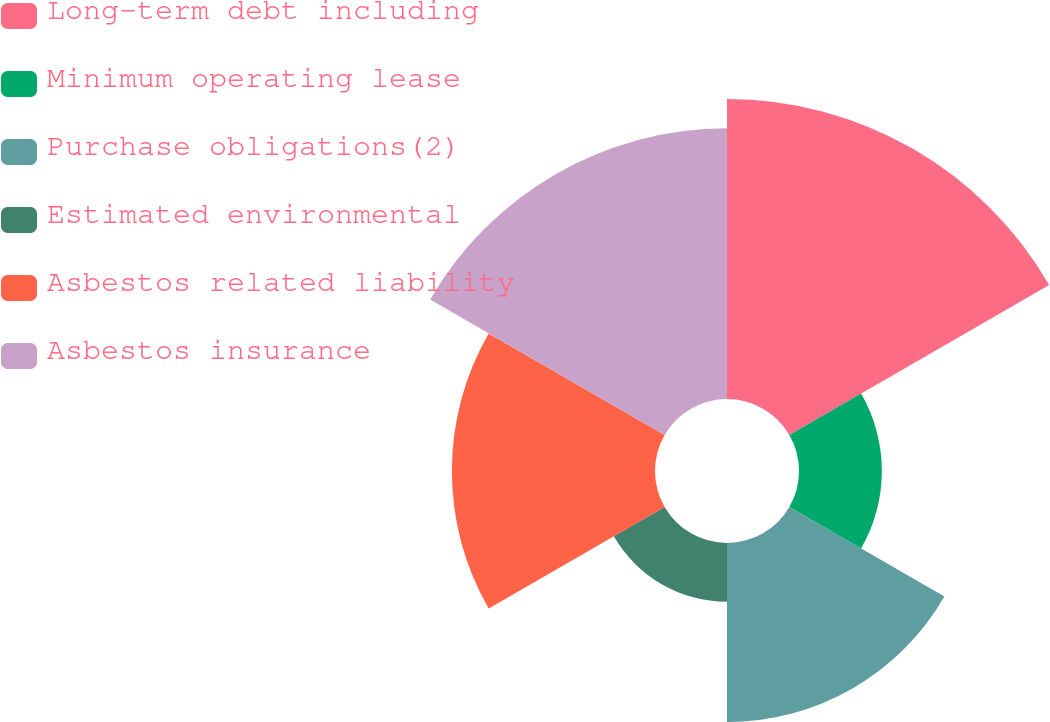<chart> <loc_0><loc_0><loc_500><loc_500><pie_chart><fcel>Long-term debt including<fcel>Minimum operating lease<fcel>Purchase obligations(2)<fcel>Estimated environmental<fcel>Asbestos related liability<fcel>Asbestos insurance<nl><fcel>27.41%<fcel>7.57%<fcel>16.36%<fcel>5.36%<fcel>18.56%<fcel>24.74%<nl></chart> 